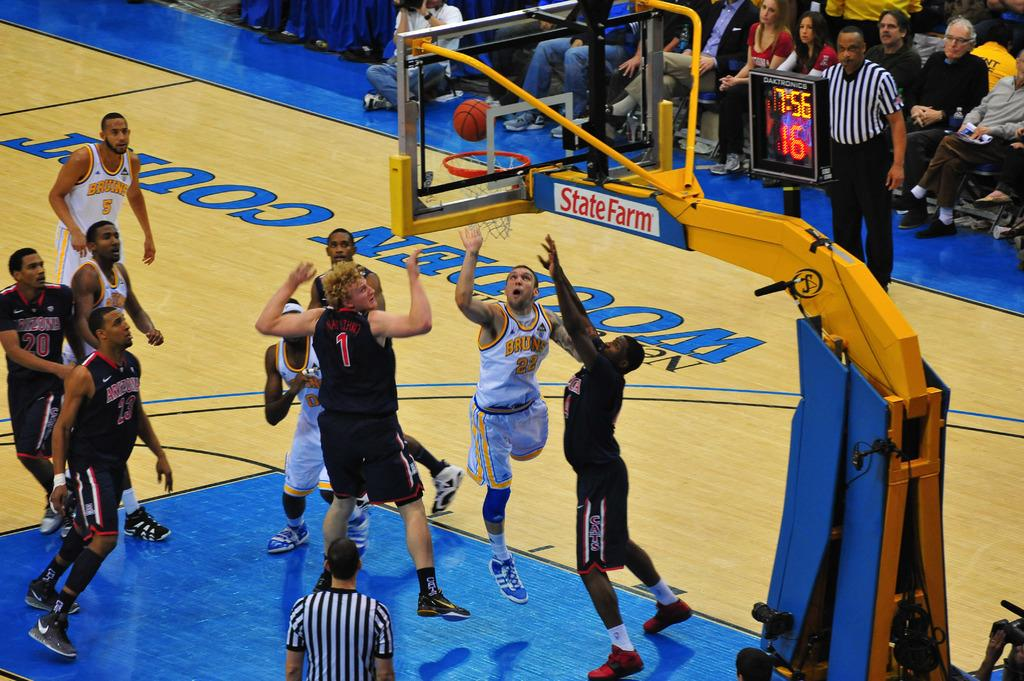<image>
Describe the image concisely. Basketball game with players with black uniforms on a Cats in red on the left of the players shorts. 